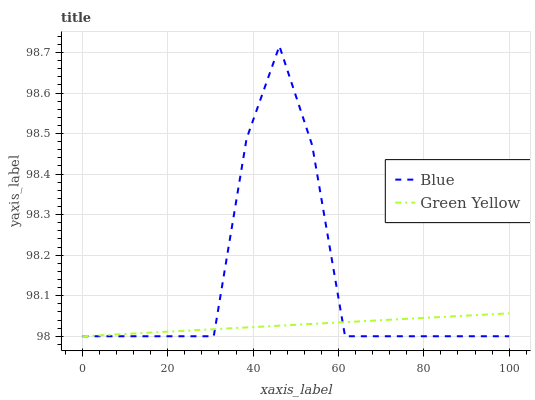Does Green Yellow have the minimum area under the curve?
Answer yes or no. Yes. Does Blue have the maximum area under the curve?
Answer yes or no. Yes. Does Green Yellow have the maximum area under the curve?
Answer yes or no. No. Is Green Yellow the smoothest?
Answer yes or no. Yes. Is Blue the roughest?
Answer yes or no. Yes. Is Green Yellow the roughest?
Answer yes or no. No. Does Blue have the lowest value?
Answer yes or no. Yes. Does Blue have the highest value?
Answer yes or no. Yes. Does Green Yellow have the highest value?
Answer yes or no. No. Does Blue intersect Green Yellow?
Answer yes or no. Yes. Is Blue less than Green Yellow?
Answer yes or no. No. Is Blue greater than Green Yellow?
Answer yes or no. No. 